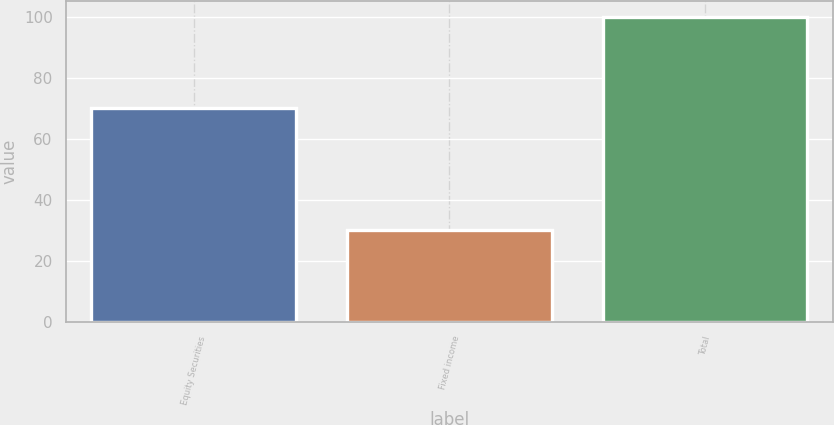Convert chart. <chart><loc_0><loc_0><loc_500><loc_500><bar_chart><fcel>Equity Securities<fcel>Fixed income<fcel>Total<nl><fcel>70<fcel>30<fcel>100<nl></chart> 